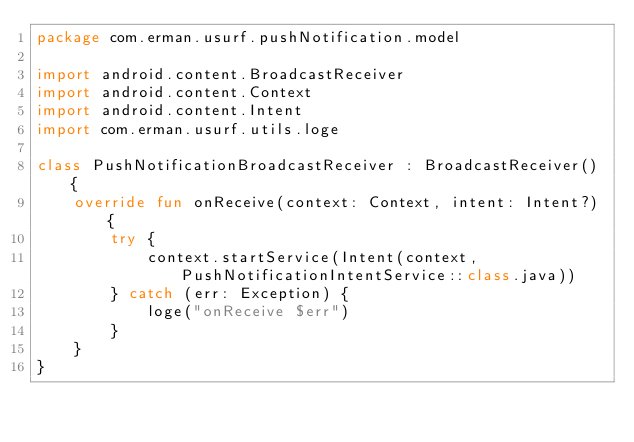<code> <loc_0><loc_0><loc_500><loc_500><_Kotlin_>package com.erman.usurf.pushNotification.model

import android.content.BroadcastReceiver
import android.content.Context
import android.content.Intent
import com.erman.usurf.utils.loge

class PushNotificationBroadcastReceiver : BroadcastReceiver() {
    override fun onReceive(context: Context, intent: Intent?) {
        try {
            context.startService(Intent(context, PushNotificationIntentService::class.java))
        } catch (err: Exception) {
            loge("onReceive $err")
        }
    }
}</code> 